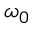<formula> <loc_0><loc_0><loc_500><loc_500>\omega _ { 0 }</formula> 